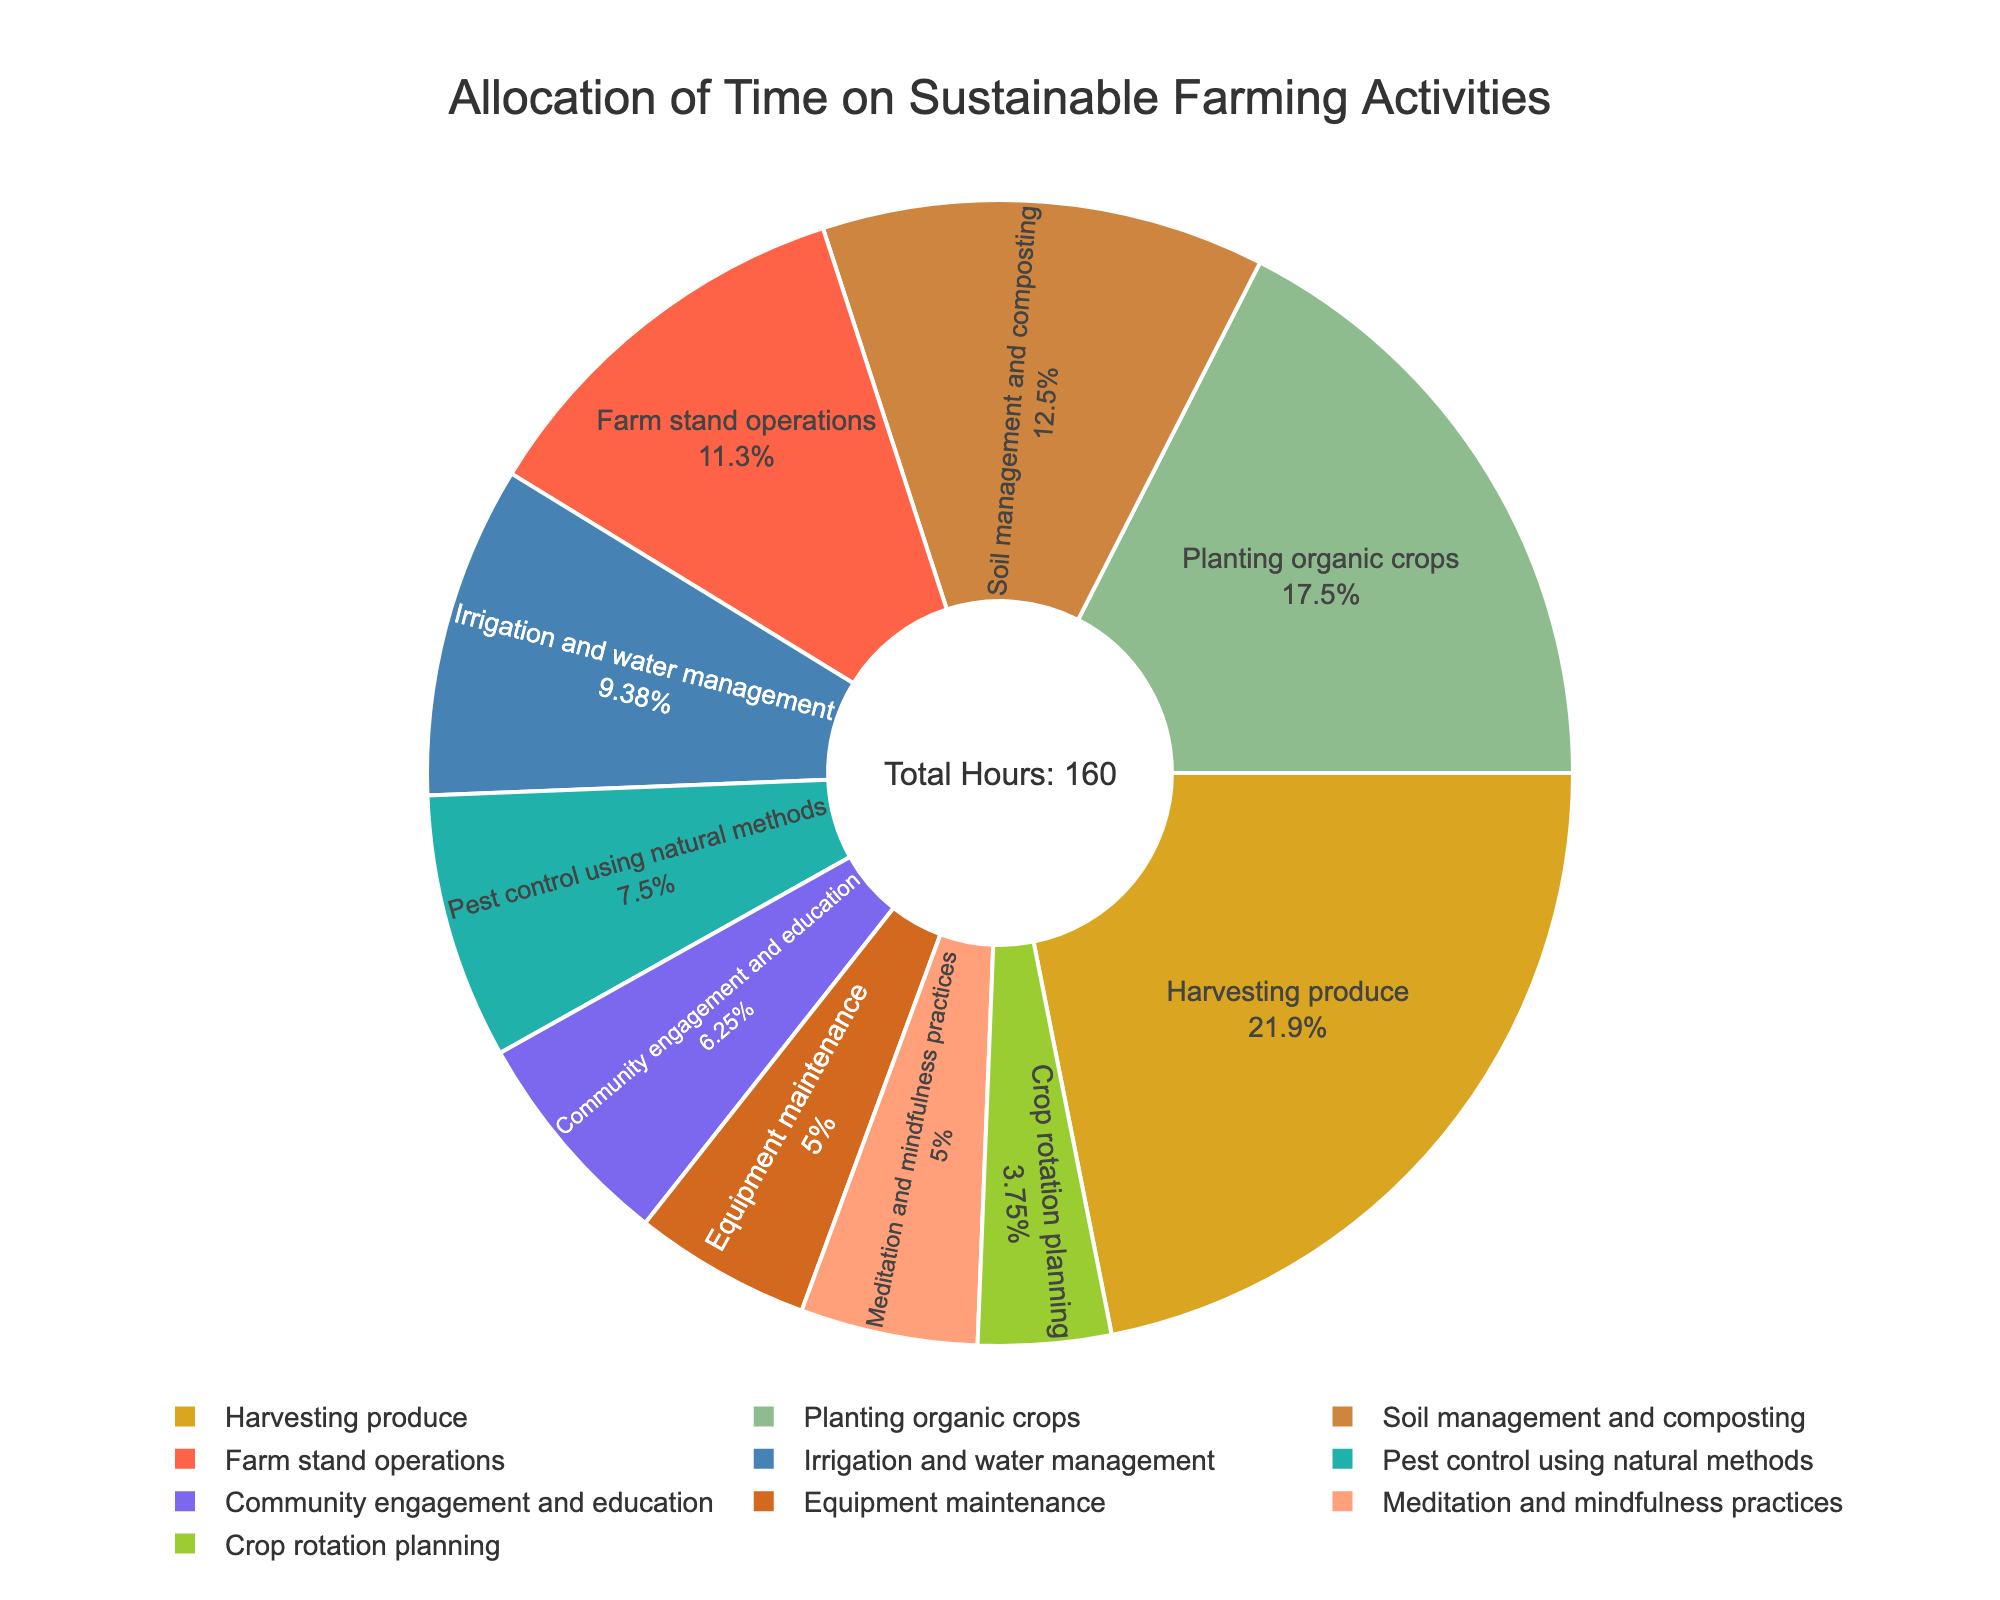What's the largest allocation of time for a single activity? By observing the pie chart, the largest slice represents the activity with the highest allocation. The "Harvesting produce" segment appears largest.
Answer: Harvesting produce What's the total time spent on soil-related activities (Soil management and composting, Pest control using natural methods)? Add the time spent on "Soil management and composting" (20 hours) and "Pest control using natural methods" (12 hours) by noticing their respective pie chart segments.
Answer: 32 hours Which activity has the smallest allocation of time? By looking at the pie chart, the smallest slice corresponds to the activity with the fewest hours. "Crop rotation planning" looks to be the smallest.
Answer: Crop rotation planning What percentage of time is spent on farm stand operations? Observe the "Farm stand operations" segment on the pie chart, which includes the percentage label within the slice. The percentage is visible directly on the chart.
Answer: 9.8% How much more time is spent on planting organic crops compared to meditation and mindfulness practices? Note the hours for "Planting organic crops" (28 hours) and "Meditation and mindfulness practices" (8 hours) from the figure. Subtract the smaller value from the larger one: 28 - 8.
Answer: 20 hours Compare the time spent on irrigation and harvesting. Which is greater, and by how much? Identify the segments for "Irrigation and water management" (15 hours) and "Harvesting produce" (35 hours). Subtract 15 from 35 to find the difference.
Answer: Harvesting produce by 20 hours Which two activities together account for approximately one-third of the total time? Summing the hours for "Harvesting produce" (35) and "Irrigation and water management" (15) gives 50 hours. The total hours are 160, and 50/160 is approximately 31.25%, close to one-third.
Answer: Harvesting produce and Irrigation and water management What color represents community engagement and education? Identify the slice labeled "Community engagement and education" on the pie chart. Note the color used for this segment, which is purple.
Answer: Purple What's the combined total time spent on equipment maintenance and community engagement and education? Add the time spent on "Equipment maintenance" (8 hours) and "Community engagement and education" (10 hours) by looking at their respective segments in the chart.
Answer: 18 hours What's the median number of hours spent on each activity? List the hours: 6, 8, 8, 10, 12, 15, 18, 20, 28, 35. Since there are 10 activities, the median is the average of the 5th and 6th values: (12 + 15)/2.
Answer: 13.5 hours 